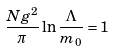Convert formula to latex. <formula><loc_0><loc_0><loc_500><loc_500>\frac { N g ^ { 2 } } { \pi } \ln \frac { \Lambda } { m _ { 0 } } = 1</formula> 